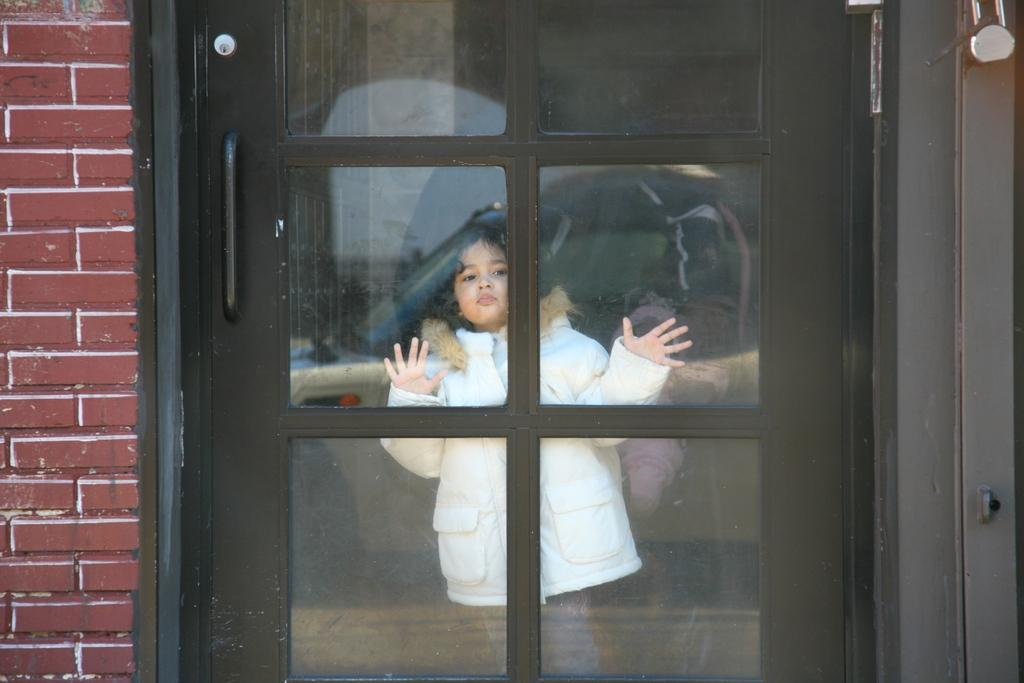What is the main subject of the image? There is a girl child in the image. What is the girl child doing in the image? The girl child is watching outside through a glass door. What can be seen beside the glass door in the image? There is a brick wall beside the glass door. What type of lift can be seen in the image? There is no lift present in the image. What sense is the girl child using to watch outside through the glass door? The girl child is using her sense of sight to watch outside through the glass door. 